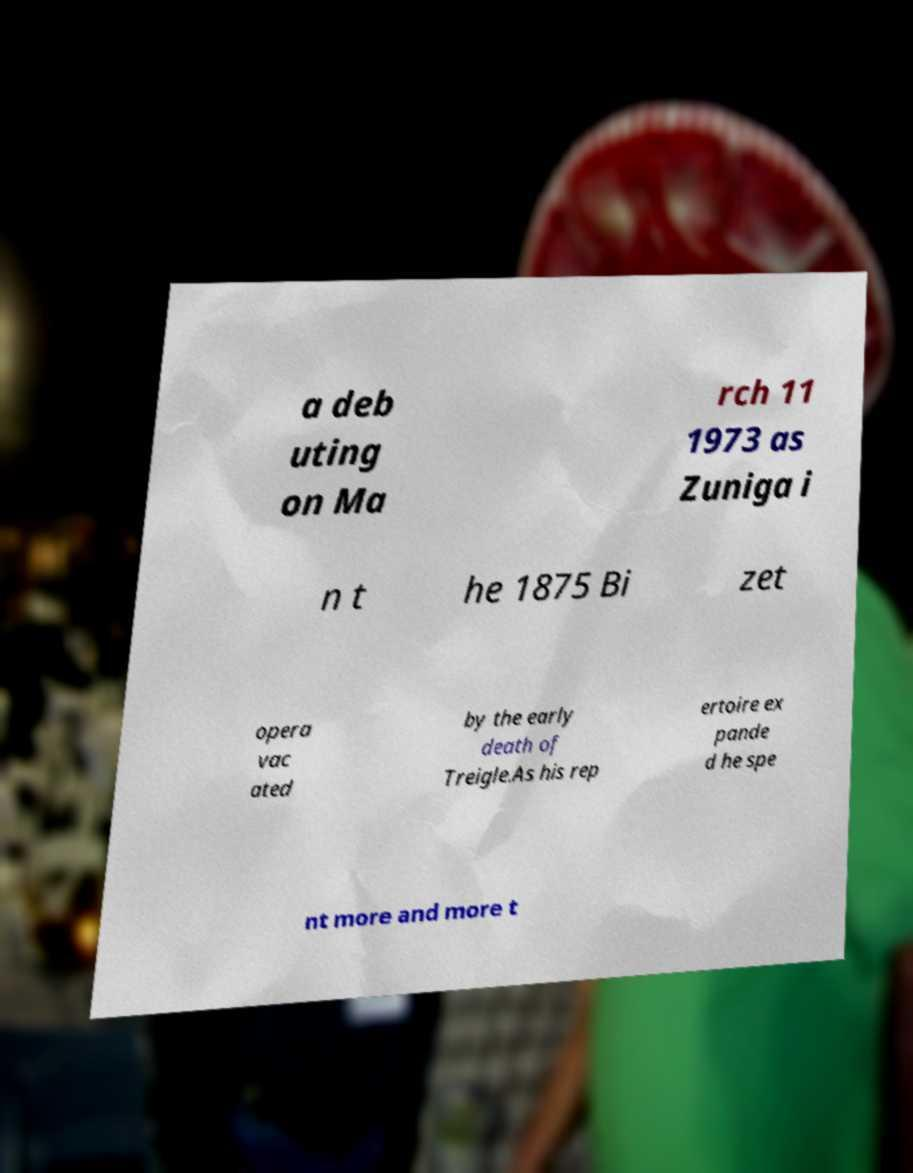Please read and relay the text visible in this image. What does it say? a deb uting on Ma rch 11 1973 as Zuniga i n t he 1875 Bi zet opera vac ated by the early death of Treigle.As his rep ertoire ex pande d he spe nt more and more t 